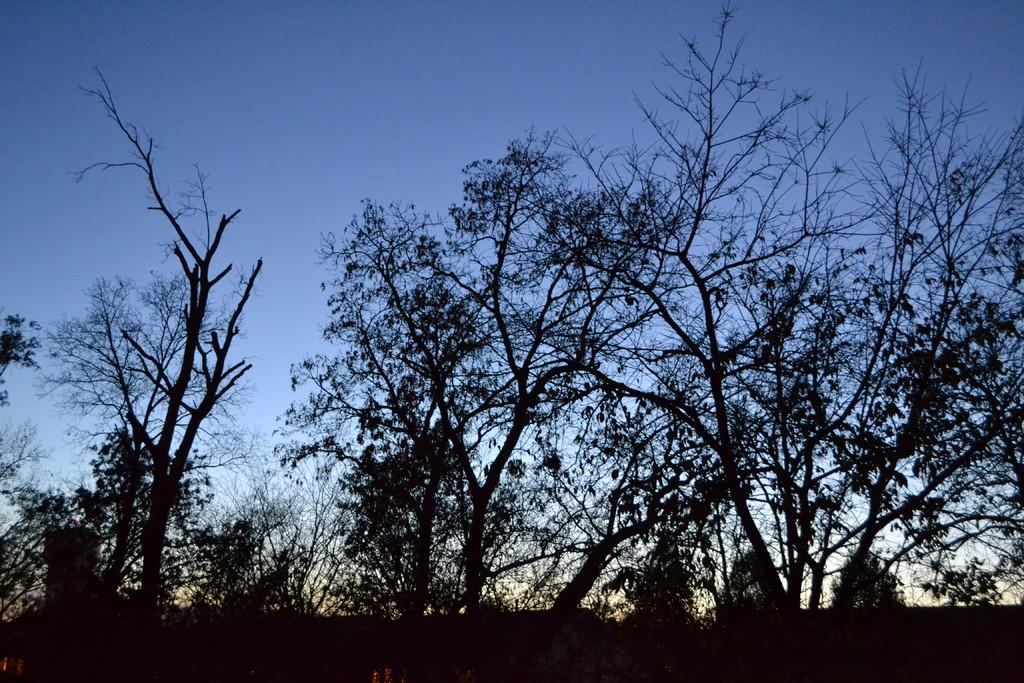What type of vegetation can be seen in the image? There are trees in the image. What part of the natural environment is visible in the image? The sky is visible in the image. What page of the book is the tree located on in the image? There is no book present in the image, so it is not possible to determine which page the tree might be on. 